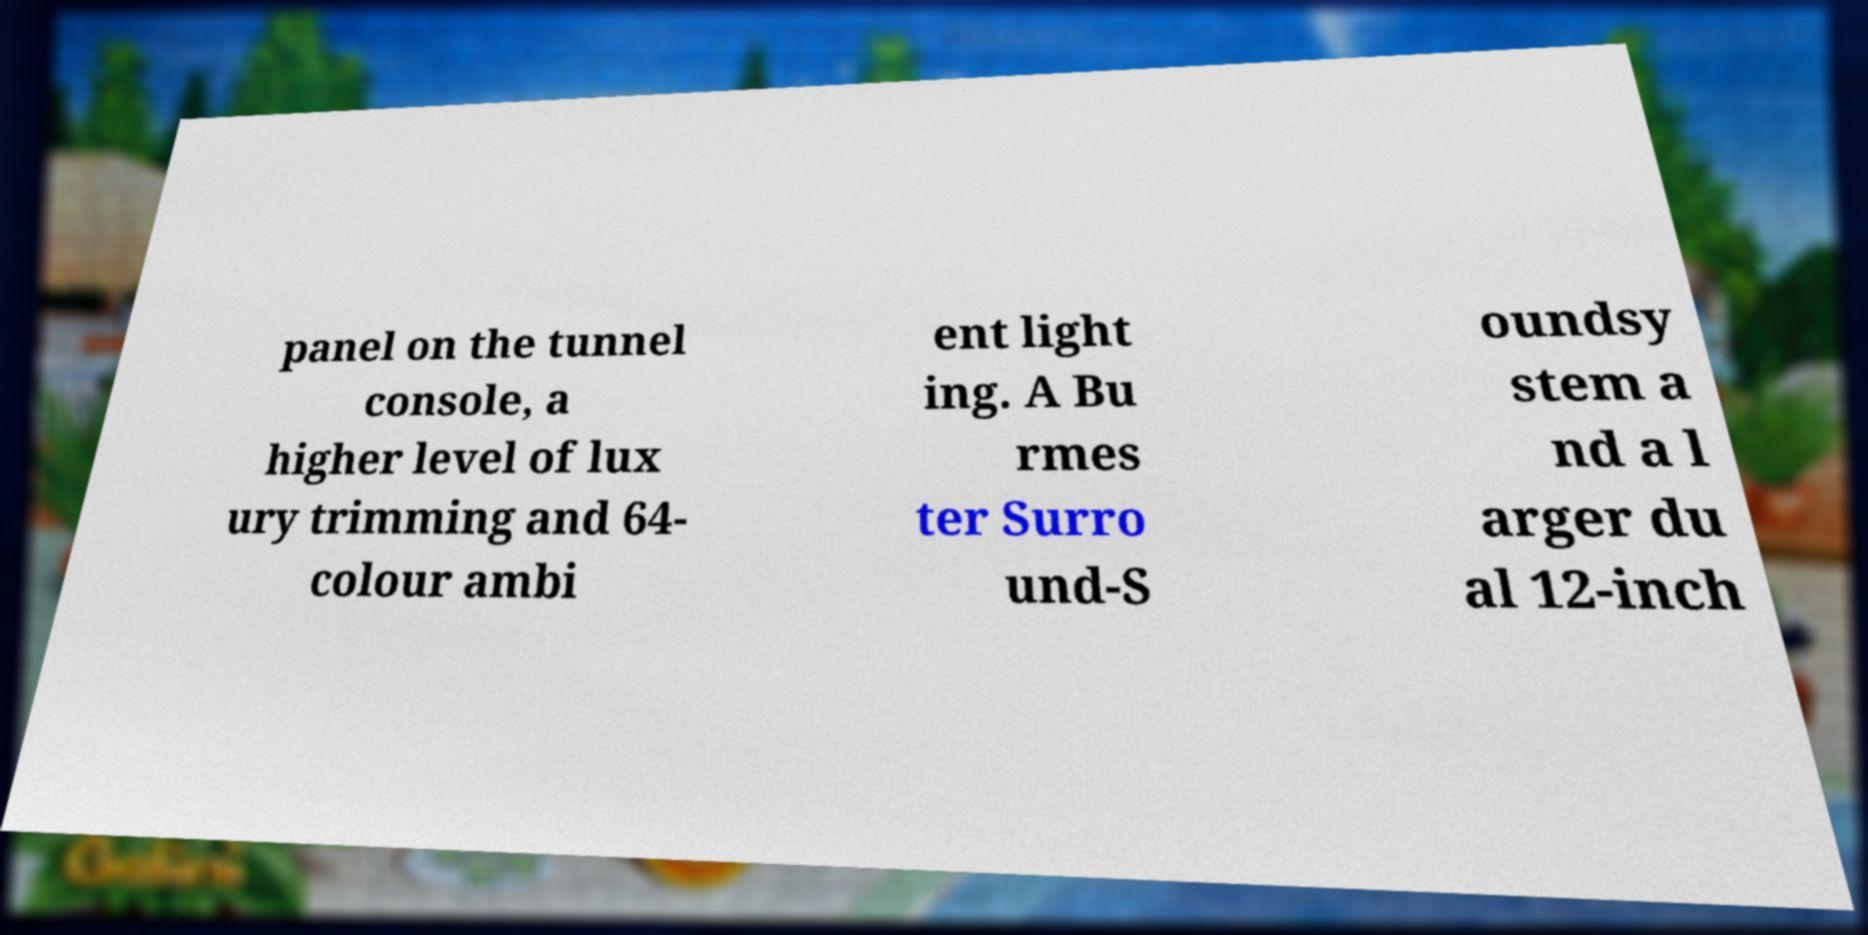Can you accurately transcribe the text from the provided image for me? panel on the tunnel console, a higher level of lux ury trimming and 64- colour ambi ent light ing. A Bu rmes ter Surro und-S oundsy stem a nd a l arger du al 12-inch 